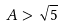Convert formula to latex. <formula><loc_0><loc_0><loc_500><loc_500>A > \sqrt { 5 }</formula> 